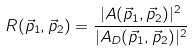Convert formula to latex. <formula><loc_0><loc_0><loc_500><loc_500>R ( \vec { p } _ { 1 } , \vec { p } _ { 2 } ) = \frac { | A ( \vec { p } _ { 1 } , \vec { p } _ { 2 } ) | ^ { 2 } } { | A _ { D } ( \vec { p } _ { 1 } , \vec { p } _ { 2 } ) | ^ { 2 } }</formula> 